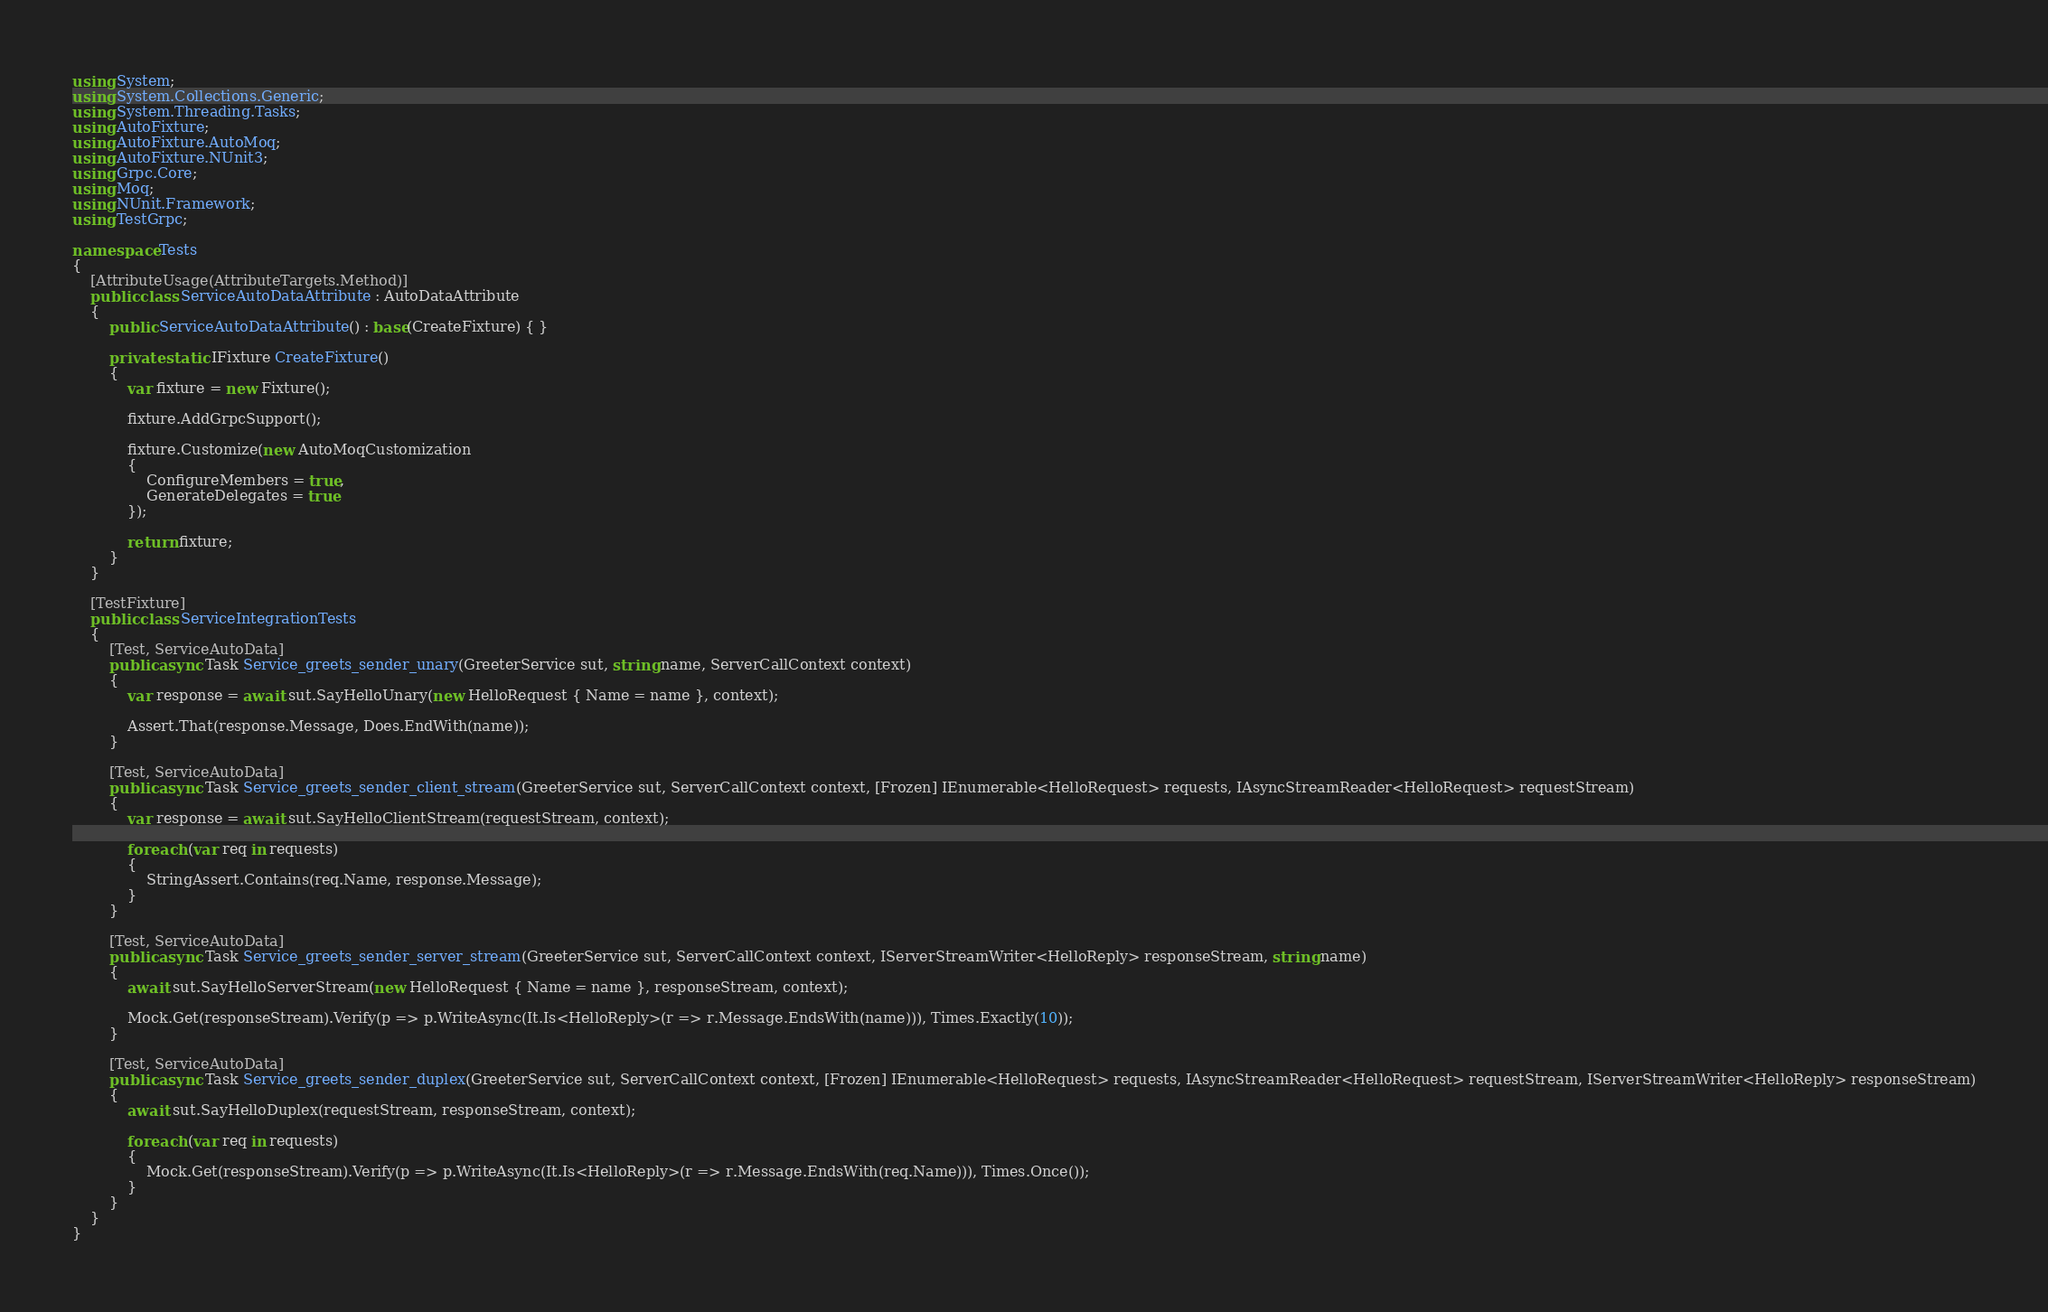<code> <loc_0><loc_0><loc_500><loc_500><_C#_>using System;
using System.Collections.Generic;
using System.Threading.Tasks;
using AutoFixture;
using AutoFixture.AutoMoq;
using AutoFixture.NUnit3;
using Grpc.Core;
using Moq;
using NUnit.Framework;
using TestGrpc;

namespace Tests
{
    [AttributeUsage(AttributeTargets.Method)]
    public class ServiceAutoDataAttribute : AutoDataAttribute
    {
        public ServiceAutoDataAttribute() : base(CreateFixture) { }

        private static IFixture CreateFixture()
        {
            var fixture = new Fixture();

            fixture.AddGrpcSupport();

            fixture.Customize(new AutoMoqCustomization
            {
                ConfigureMembers = true,
                GenerateDelegates = true
            });

            return fixture;
        }
    }

    [TestFixture]
    public class ServiceIntegrationTests
    {
        [Test, ServiceAutoData]
        public async Task Service_greets_sender_unary(GreeterService sut, string name, ServerCallContext context)
        {
            var response = await sut.SayHelloUnary(new HelloRequest { Name = name }, context);

            Assert.That(response.Message, Does.EndWith(name));
        }

        [Test, ServiceAutoData]
        public async Task Service_greets_sender_client_stream(GreeterService sut, ServerCallContext context, [Frozen] IEnumerable<HelloRequest> requests, IAsyncStreamReader<HelloRequest> requestStream)
        {
            var response = await sut.SayHelloClientStream(requestStream, context);

            foreach (var req in requests)
            {
                StringAssert.Contains(req.Name, response.Message);
            }
        }

        [Test, ServiceAutoData]
        public async Task Service_greets_sender_server_stream(GreeterService sut, ServerCallContext context, IServerStreamWriter<HelloReply> responseStream, string name)
        {
            await sut.SayHelloServerStream(new HelloRequest { Name = name }, responseStream, context);

            Mock.Get(responseStream).Verify(p => p.WriteAsync(It.Is<HelloReply>(r => r.Message.EndsWith(name))), Times.Exactly(10));
        }

        [Test, ServiceAutoData]
        public async Task Service_greets_sender_duplex(GreeterService sut, ServerCallContext context, [Frozen] IEnumerable<HelloRequest> requests, IAsyncStreamReader<HelloRequest> requestStream, IServerStreamWriter<HelloReply> responseStream)
        {
            await sut.SayHelloDuplex(requestStream, responseStream, context);

            foreach (var req in requests)
            {
                Mock.Get(responseStream).Verify(p => p.WriteAsync(It.Is<HelloReply>(r => r.Message.EndsWith(req.Name))), Times.Once());
            }
        }
    }
}</code> 